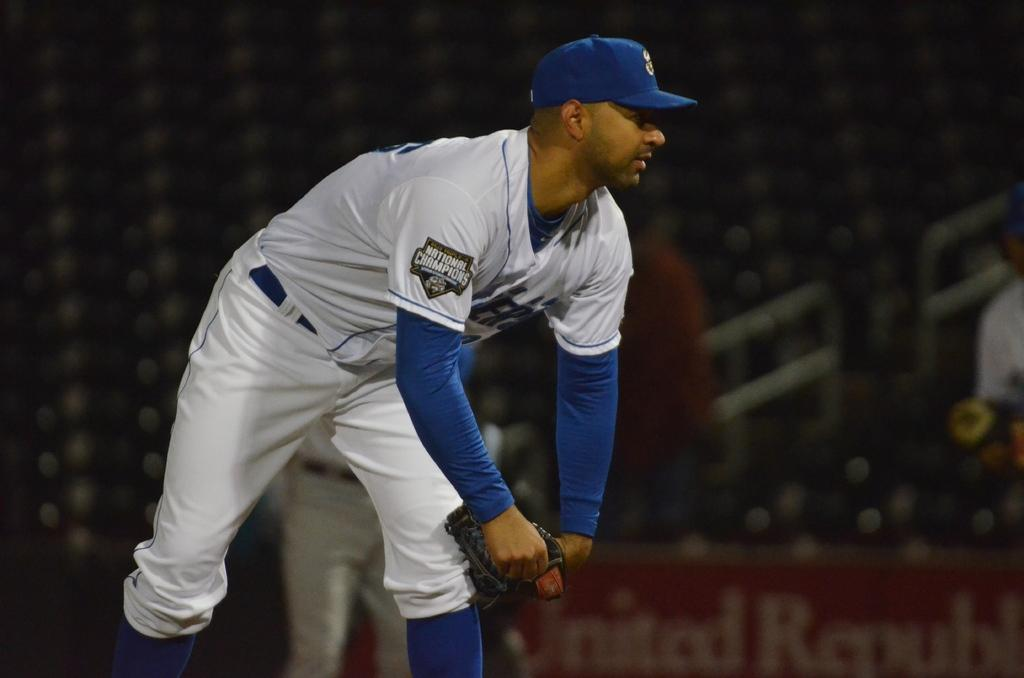<image>
Create a compact narrative representing the image presented. a player with a white jersey that says national champions 